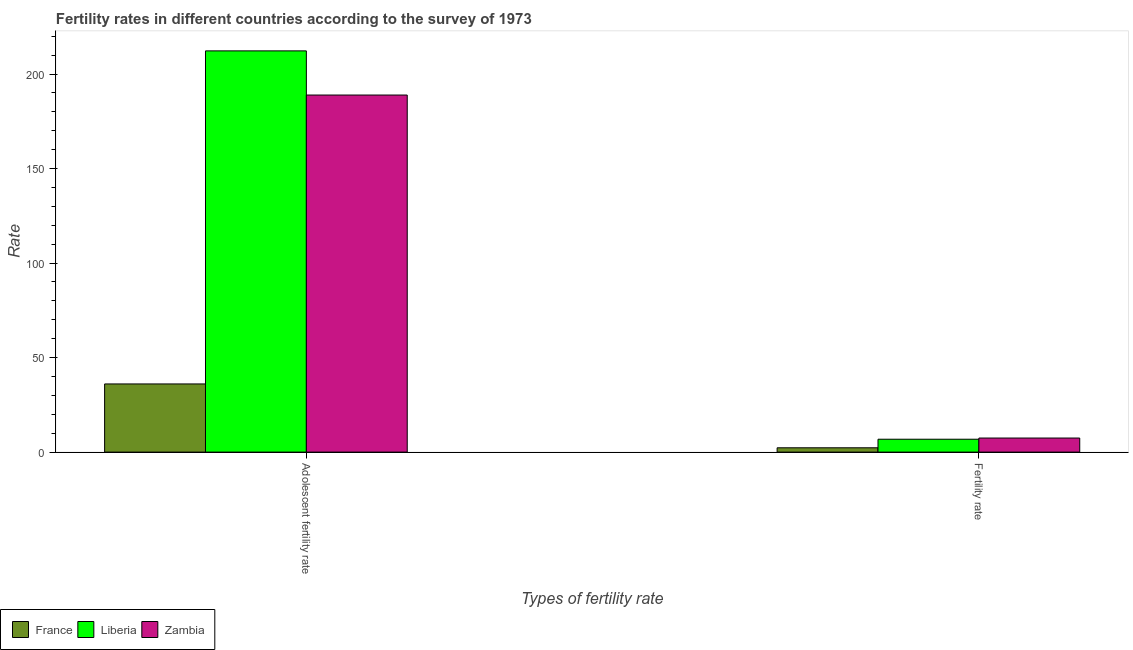How many different coloured bars are there?
Make the answer very short. 3. Are the number of bars per tick equal to the number of legend labels?
Ensure brevity in your answer.  Yes. Are the number of bars on each tick of the X-axis equal?
Ensure brevity in your answer.  Yes. How many bars are there on the 2nd tick from the left?
Ensure brevity in your answer.  3. What is the label of the 2nd group of bars from the left?
Provide a short and direct response. Fertility rate. What is the adolescent fertility rate in Zambia?
Provide a succinct answer. 188.87. Across all countries, what is the maximum fertility rate?
Offer a very short reply. 7.44. Across all countries, what is the minimum fertility rate?
Ensure brevity in your answer.  2.28. In which country was the adolescent fertility rate maximum?
Offer a terse response. Liberia. In which country was the adolescent fertility rate minimum?
Your answer should be compact. France. What is the total fertility rate in the graph?
Provide a short and direct response. 16.54. What is the difference between the adolescent fertility rate in Zambia and that in Liberia?
Give a very brief answer. -23.35. What is the difference between the fertility rate in France and the adolescent fertility rate in Liberia?
Your answer should be compact. -209.95. What is the average fertility rate per country?
Offer a terse response. 5.51. What is the difference between the fertility rate and adolescent fertility rate in Zambia?
Your answer should be compact. -181.43. In how many countries, is the adolescent fertility rate greater than 140 ?
Offer a very short reply. 2. What is the ratio of the adolescent fertility rate in Liberia to that in Zambia?
Your answer should be compact. 1.12. Is the adolescent fertility rate in Liberia less than that in France?
Provide a short and direct response. No. What does the 2nd bar from the left in Fertility rate represents?
Give a very brief answer. Liberia. What does the 3rd bar from the right in Fertility rate represents?
Give a very brief answer. France. How many bars are there?
Provide a short and direct response. 6. Are all the bars in the graph horizontal?
Give a very brief answer. No. How many countries are there in the graph?
Make the answer very short. 3. Does the graph contain grids?
Provide a succinct answer. No. Where does the legend appear in the graph?
Provide a short and direct response. Bottom left. How many legend labels are there?
Your response must be concise. 3. What is the title of the graph?
Your answer should be very brief. Fertility rates in different countries according to the survey of 1973. Does "Kuwait" appear as one of the legend labels in the graph?
Offer a very short reply. No. What is the label or title of the X-axis?
Provide a short and direct response. Types of fertility rate. What is the label or title of the Y-axis?
Keep it short and to the point. Rate. What is the Rate of France in Adolescent fertility rate?
Offer a very short reply. 36.05. What is the Rate of Liberia in Adolescent fertility rate?
Keep it short and to the point. 212.23. What is the Rate of Zambia in Adolescent fertility rate?
Offer a very short reply. 188.87. What is the Rate of France in Fertility rate?
Provide a short and direct response. 2.28. What is the Rate in Liberia in Fertility rate?
Offer a terse response. 6.82. What is the Rate in Zambia in Fertility rate?
Give a very brief answer. 7.44. Across all Types of fertility rate, what is the maximum Rate in France?
Ensure brevity in your answer.  36.05. Across all Types of fertility rate, what is the maximum Rate in Liberia?
Your answer should be very brief. 212.23. Across all Types of fertility rate, what is the maximum Rate in Zambia?
Your answer should be very brief. 188.87. Across all Types of fertility rate, what is the minimum Rate of France?
Ensure brevity in your answer.  2.28. Across all Types of fertility rate, what is the minimum Rate in Liberia?
Keep it short and to the point. 6.82. Across all Types of fertility rate, what is the minimum Rate in Zambia?
Provide a short and direct response. 7.44. What is the total Rate in France in the graph?
Make the answer very short. 38.34. What is the total Rate of Liberia in the graph?
Make the answer very short. 219.04. What is the total Rate in Zambia in the graph?
Your answer should be compact. 196.32. What is the difference between the Rate in France in Adolescent fertility rate and that in Fertility rate?
Your response must be concise. 33.77. What is the difference between the Rate of Liberia in Adolescent fertility rate and that in Fertility rate?
Give a very brief answer. 205.41. What is the difference between the Rate in Zambia in Adolescent fertility rate and that in Fertility rate?
Your response must be concise. 181.43. What is the difference between the Rate in France in Adolescent fertility rate and the Rate in Liberia in Fertility rate?
Give a very brief answer. 29.24. What is the difference between the Rate in France in Adolescent fertility rate and the Rate in Zambia in Fertility rate?
Your answer should be compact. 28.61. What is the difference between the Rate in Liberia in Adolescent fertility rate and the Rate in Zambia in Fertility rate?
Your answer should be compact. 204.78. What is the average Rate in France per Types of fertility rate?
Provide a succinct answer. 19.17. What is the average Rate in Liberia per Types of fertility rate?
Offer a terse response. 109.52. What is the average Rate of Zambia per Types of fertility rate?
Your answer should be compact. 98.16. What is the difference between the Rate in France and Rate in Liberia in Adolescent fertility rate?
Offer a very short reply. -176.17. What is the difference between the Rate in France and Rate in Zambia in Adolescent fertility rate?
Provide a succinct answer. -152.82. What is the difference between the Rate of Liberia and Rate of Zambia in Adolescent fertility rate?
Your answer should be very brief. 23.35. What is the difference between the Rate in France and Rate in Liberia in Fertility rate?
Give a very brief answer. -4.54. What is the difference between the Rate of France and Rate of Zambia in Fertility rate?
Your response must be concise. -5.16. What is the difference between the Rate in Liberia and Rate in Zambia in Fertility rate?
Provide a succinct answer. -0.63. What is the ratio of the Rate in France in Adolescent fertility rate to that in Fertility rate?
Provide a short and direct response. 15.81. What is the ratio of the Rate of Liberia in Adolescent fertility rate to that in Fertility rate?
Your answer should be very brief. 31.14. What is the ratio of the Rate in Zambia in Adolescent fertility rate to that in Fertility rate?
Your response must be concise. 25.37. What is the difference between the highest and the second highest Rate of France?
Ensure brevity in your answer.  33.77. What is the difference between the highest and the second highest Rate of Liberia?
Give a very brief answer. 205.41. What is the difference between the highest and the second highest Rate of Zambia?
Your answer should be compact. 181.43. What is the difference between the highest and the lowest Rate in France?
Your response must be concise. 33.77. What is the difference between the highest and the lowest Rate of Liberia?
Keep it short and to the point. 205.41. What is the difference between the highest and the lowest Rate of Zambia?
Your response must be concise. 181.43. 